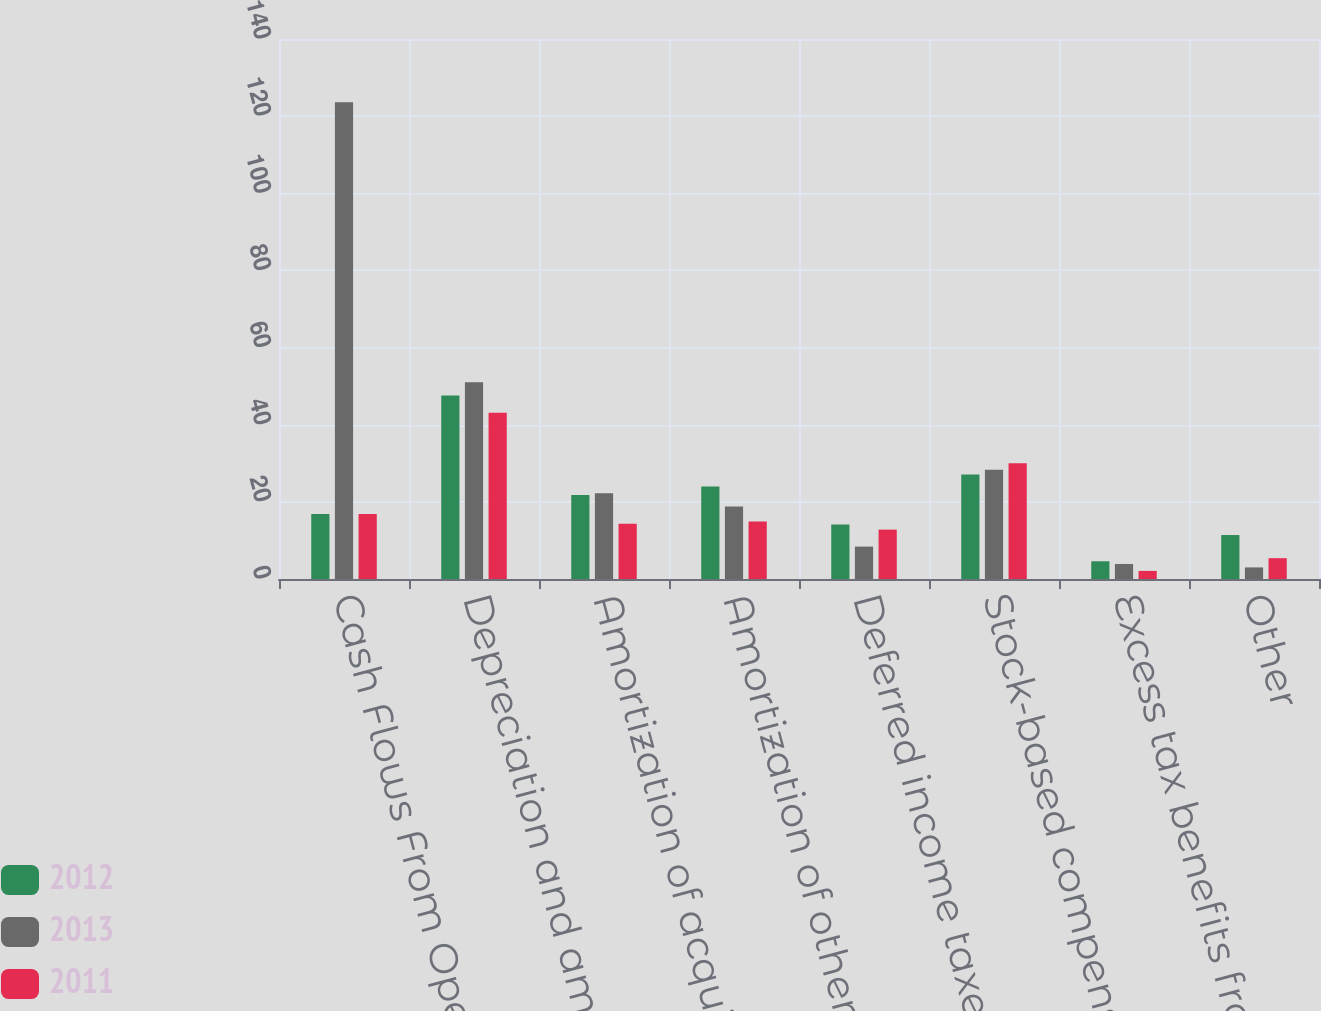Convert chart. <chart><loc_0><loc_0><loc_500><loc_500><stacked_bar_chart><ecel><fcel>Cash Flows From Operating<fcel>Depreciation and amortization<fcel>Amortization of acquired<fcel>Amortization of other assets<fcel>Deferred income taxes<fcel>Stock-based compensation<fcel>Excess tax benefits from the<fcel>Other<nl><fcel>2012<fcel>16.85<fcel>47.6<fcel>21.8<fcel>24<fcel>14.1<fcel>27.1<fcel>4.6<fcel>11.4<nl><fcel>2013<fcel>123.6<fcel>51<fcel>22.2<fcel>18.8<fcel>8.4<fcel>28.3<fcel>3.9<fcel>3<nl><fcel>2011<fcel>16.85<fcel>43.1<fcel>14.3<fcel>14.9<fcel>12.8<fcel>30<fcel>2.1<fcel>5.4<nl></chart> 